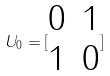<formula> <loc_0><loc_0><loc_500><loc_500>U _ { 0 } = [ \begin{matrix} 0 & 1 \\ 1 & 0 \end{matrix} ]</formula> 